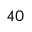Convert formula to latex. <formula><loc_0><loc_0><loc_500><loc_500>4 0</formula> 